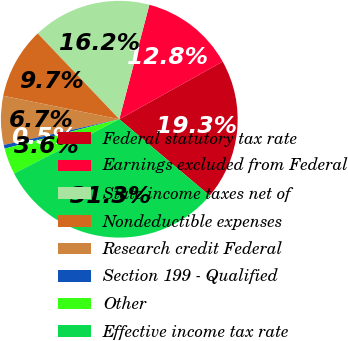<chart> <loc_0><loc_0><loc_500><loc_500><pie_chart><fcel>Federal statutory tax rate<fcel>Earnings excluded from Federal<fcel>State income taxes net of<fcel>Nondeductible expenses<fcel>Research credit Federal<fcel>Section 199 - Qualified<fcel>Other<fcel>Effective income tax rate<nl><fcel>19.26%<fcel>12.81%<fcel>16.19%<fcel>9.73%<fcel>6.66%<fcel>0.51%<fcel>3.58%<fcel>31.26%<nl></chart> 